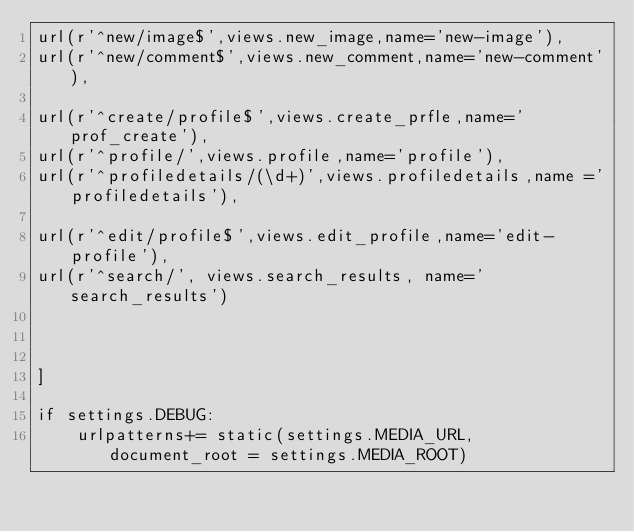Convert code to text. <code><loc_0><loc_0><loc_500><loc_500><_Python_>url(r'^new/image$',views.new_image,name='new-image'),
url(r'^new/comment$',views.new_comment,name='new-comment'),

url(r'^create/profile$',views.create_prfle,name='prof_create'),
url(r'^profile/',views.profile,name='profile'),
url(r'^profiledetails/(\d+)',views.profiledetails,name ='profiledetails'),

url(r'^edit/profile$',views.edit_profile,name='edit-profile'),
url(r'^search/', views.search_results, name='search_results')



]

if settings.DEBUG:
    urlpatterns+= static(settings.MEDIA_URL, document_root = settings.MEDIA_ROOT)</code> 